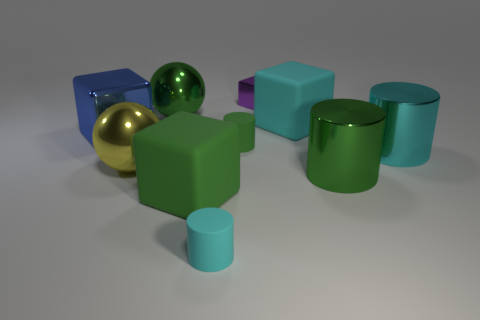What is the shape of the cyan rubber thing that is in front of the green shiny object that is in front of the cyan cube?
Offer a very short reply. Cylinder. There is a metallic cube that is behind the blue cube; how big is it?
Ensure brevity in your answer.  Small. Do the small cyan cylinder and the purple thing have the same material?
Give a very brief answer. No. There is another cyan object that is made of the same material as the tiny cyan object; what shape is it?
Give a very brief answer. Cube. What is the color of the large metallic sphere behind the big cyan rubber thing?
Offer a very short reply. Green. There is a blue object that is the same shape as the purple object; what is its material?
Provide a short and direct response. Metal. How many green metallic things are the same size as the cyan matte block?
Your answer should be very brief. 2. There is a rubber thing that is both to the right of the cyan rubber cylinder and in front of the large cyan cube; what size is it?
Your answer should be very brief. Small. What is the big cube that is on the right side of the small cyan matte thing made of?
Offer a very short reply. Rubber. The block that is in front of the large cyan matte cube and behind the cyan metal object is what color?
Give a very brief answer. Blue. 